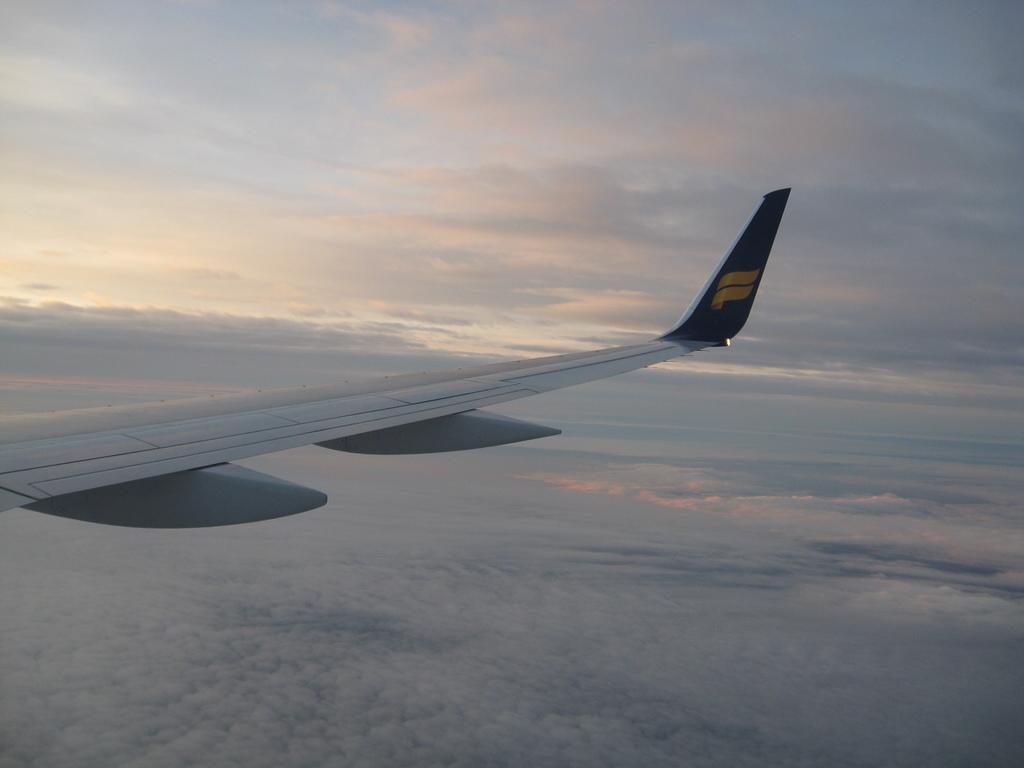Can you describe this image briefly? This image consists of an airplane wing. There are clouds in this image. 